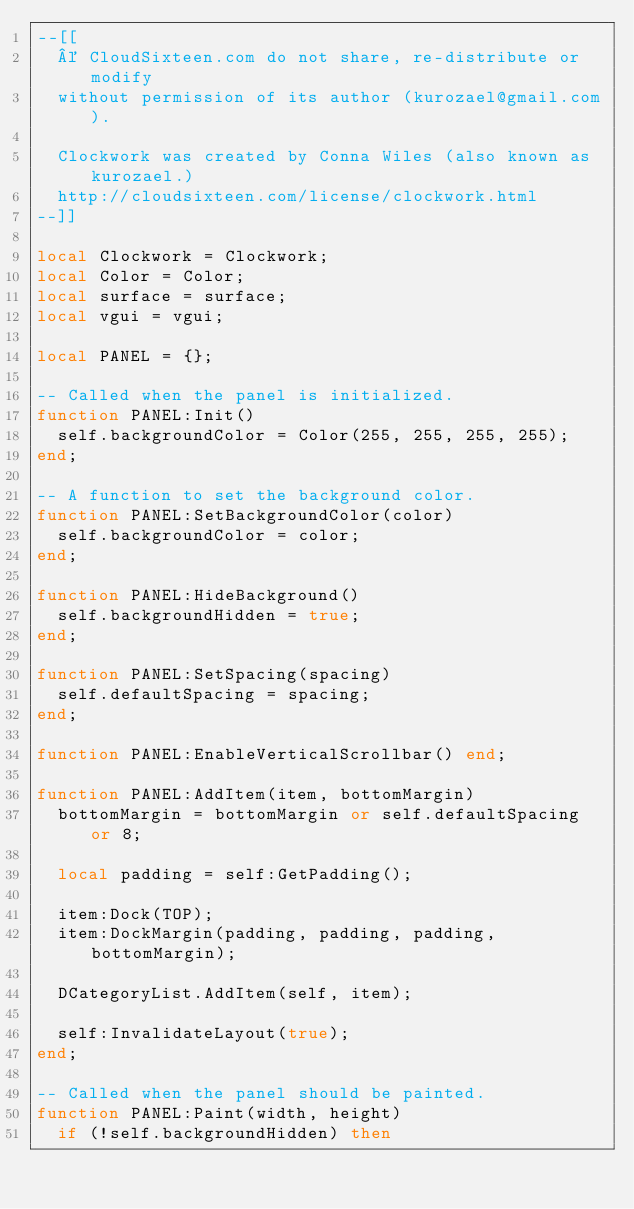Convert code to text. <code><loc_0><loc_0><loc_500><loc_500><_Lua_>--[[
	© CloudSixteen.com do not share, re-distribute or modify
	without permission of its author (kurozael@gmail.com).

	Clockwork was created by Conna Wiles (also known as kurozael.)
	http://cloudsixteen.com/license/clockwork.html
--]]

local Clockwork = Clockwork;
local Color = Color;
local surface = surface;
local vgui = vgui;

local PANEL = {};

-- Called when the panel is initialized.
function PANEL:Init()
	self.backgroundColor = Color(255, 255, 255, 255);
end;

-- A function to set the background color.
function PANEL:SetBackgroundColor(color)
	self.backgroundColor = color;
end;

function PANEL:HideBackground()
	self.backgroundHidden = true;
end;

function PANEL:SetSpacing(spacing)
	self.defaultSpacing = spacing;
end;

function PANEL:EnableVerticalScrollbar() end;

function PANEL:AddItem(item, bottomMargin)
	bottomMargin = bottomMargin or self.defaultSpacing or 8;
	
	local padding = self:GetPadding();
	
	item:Dock(TOP);
	item:DockMargin(padding, padding, padding, bottomMargin);
	
	DCategoryList.AddItem(self, item);
	
	self:InvalidateLayout(true);
end;

-- Called when the panel should be painted.
function PANEL:Paint(width, height)
	if (!self.backgroundHidden) then</code> 